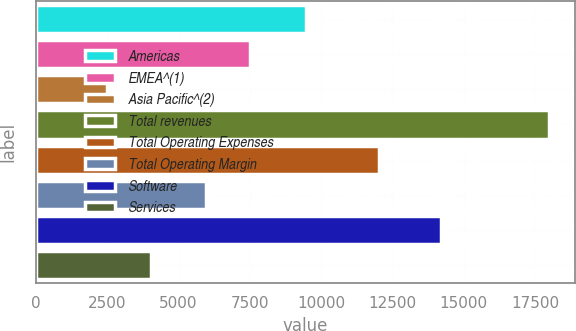<chart> <loc_0><loc_0><loc_500><loc_500><bar_chart><fcel>Americas<fcel>EMEA^(1)<fcel>Asia Pacific^(2)<fcel>Total revenues<fcel>Total Operating Expenses<fcel>Total Operating Margin<fcel>Software<fcel>Services<nl><fcel>9460<fcel>7523.7<fcel>2499<fcel>17996<fcel>12022<fcel>5974<fcel>14211<fcel>4048.7<nl></chart> 